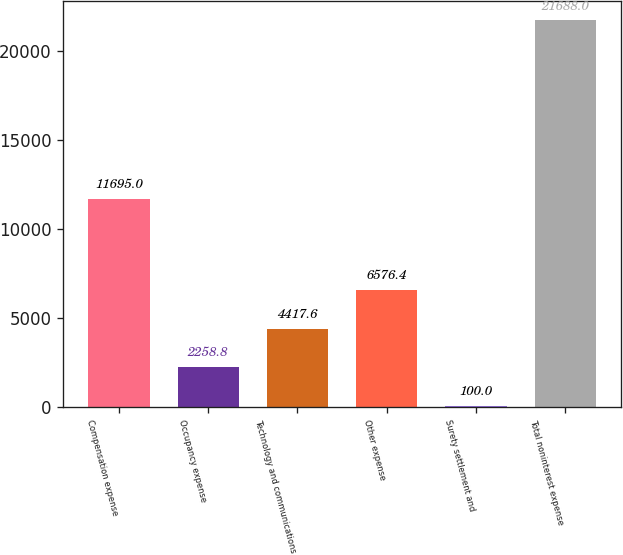Convert chart to OTSL. <chart><loc_0><loc_0><loc_500><loc_500><bar_chart><fcel>Compensation expense<fcel>Occupancy expense<fcel>Technology and communications<fcel>Other expense<fcel>Surety settlement and<fcel>Total noninterest expense<nl><fcel>11695<fcel>2258.8<fcel>4417.6<fcel>6576.4<fcel>100<fcel>21688<nl></chart> 